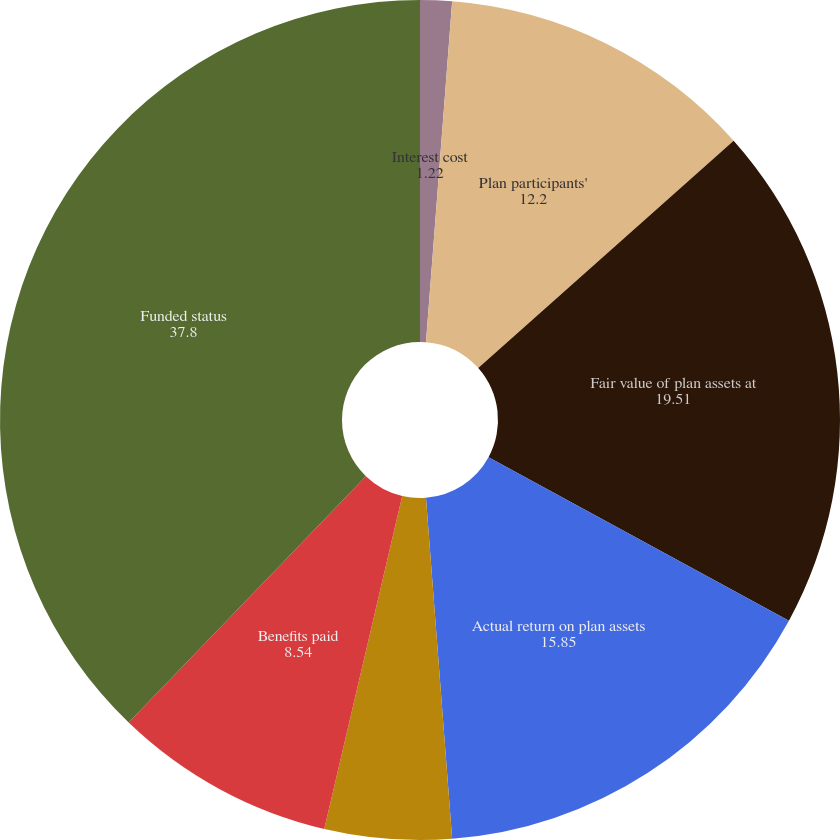Convert chart. <chart><loc_0><loc_0><loc_500><loc_500><pie_chart><fcel>Interest cost<fcel>Plan participants'<fcel>Fair value of plan assets at<fcel>Actual return on plan assets<fcel>Employer contributions<fcel>Benefits paid<fcel>Funded status<nl><fcel>1.22%<fcel>12.2%<fcel>19.51%<fcel>15.85%<fcel>4.88%<fcel>8.54%<fcel>37.8%<nl></chart> 